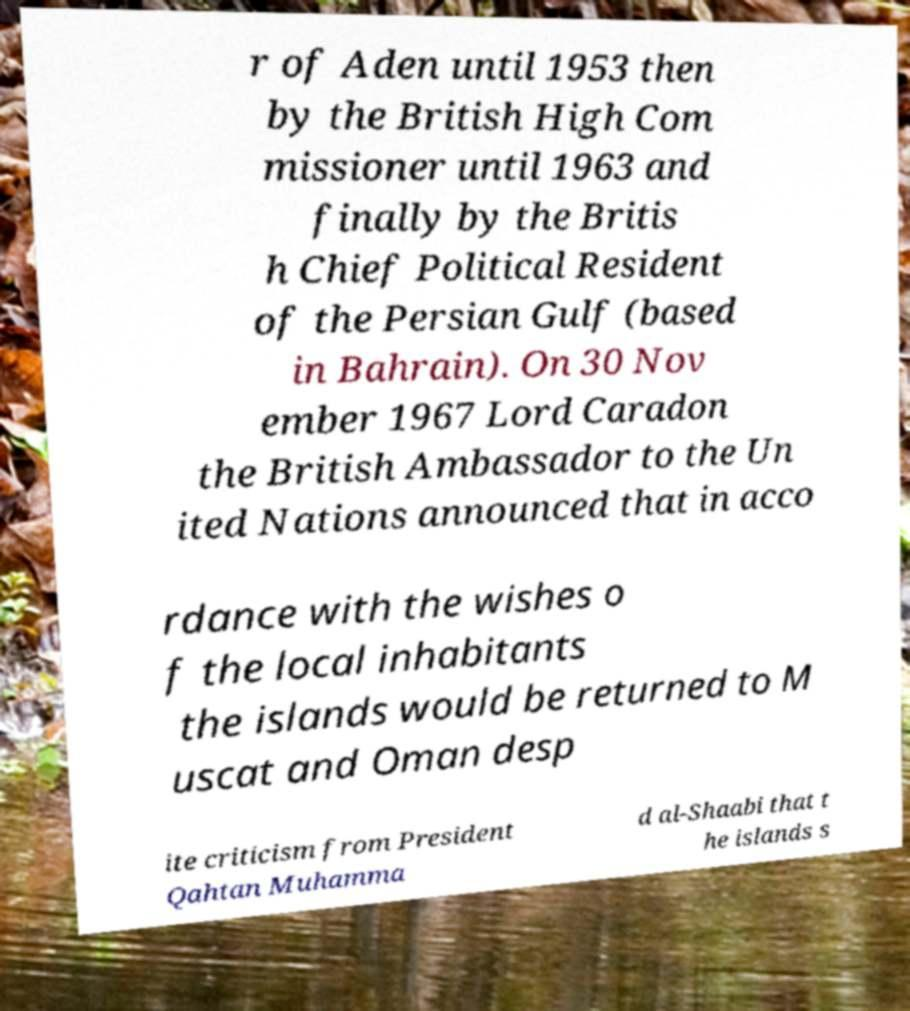Can you read and provide the text displayed in the image?This photo seems to have some interesting text. Can you extract and type it out for me? r of Aden until 1953 then by the British High Com missioner until 1963 and finally by the Britis h Chief Political Resident of the Persian Gulf (based in Bahrain). On 30 Nov ember 1967 Lord Caradon the British Ambassador to the Un ited Nations announced that in acco rdance with the wishes o f the local inhabitants the islands would be returned to M uscat and Oman desp ite criticism from President Qahtan Muhamma d al-Shaabi that t he islands s 